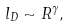<formula> <loc_0><loc_0><loc_500><loc_500>l _ { D } \sim R ^ { \gamma } ,</formula> 